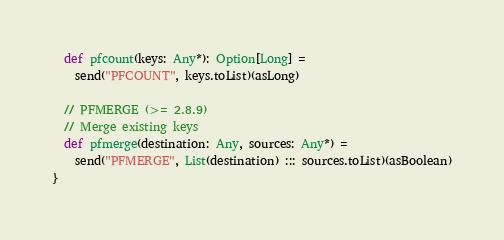Convert code to text. <code><loc_0><loc_0><loc_500><loc_500><_Scala_>  def pfcount(keys: Any*): Option[Long] =
    send("PFCOUNT", keys.toList)(asLong)

  // PFMERGE (>= 2.8.9)
  // Merge existing keys
  def pfmerge(destination: Any, sources: Any*) =
    send("PFMERGE", List(destination) ::: sources.toList)(asBoolean)
}
</code> 